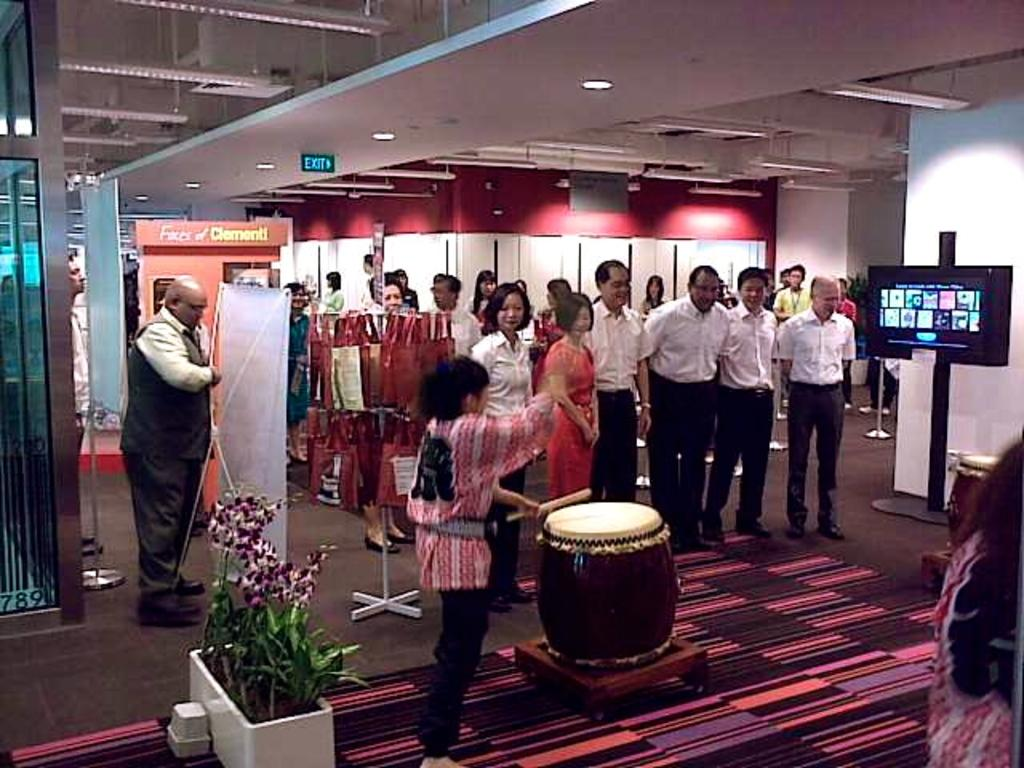What are the people in the image doing? The persons standing on the floor are likely participating in an event or gathering. What musical instrument can be seen in the image? There is a drum in the image. What type of signage is present in the image? There is a banner in the image. What type of vegetation is present in the image? There is a plant in the image. What type of display device is present in the image? There is a screen in the image. What type of architectural feature is present in the image? There is a wall in the image. What type of lighting is present in the image? There are lights in the image. What year is depicted on the banner in the image? There is no year mentioned on the banner in the image. What type of dress is the plant wearing in the image? The plant is not wearing any dress; it is a natural vegetation. 